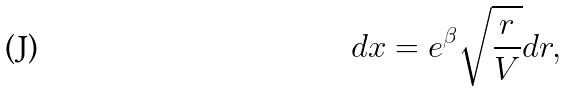Convert formula to latex. <formula><loc_0><loc_0><loc_500><loc_500>d x = e ^ { \beta } \sqrt { \frac { r } { V } } d r ,</formula> 